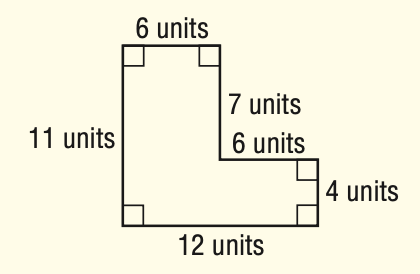Question: What is the perimeter of the figure?
Choices:
A. 20
B. 46
C. 90
D. 132
Answer with the letter. Answer: A 